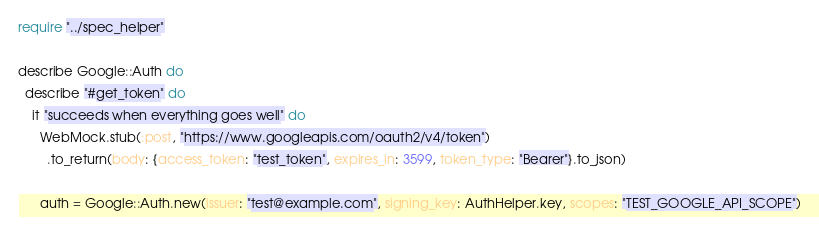<code> <loc_0><loc_0><loc_500><loc_500><_Crystal_>require "../spec_helper"

describe Google::Auth do
  describe "#get_token" do
    it "succeeds when everything goes well" do
      WebMock.stub(:post, "https://www.googleapis.com/oauth2/v4/token")
        .to_return(body: {access_token: "test_token", expires_in: 3599, token_type: "Bearer"}.to_json)

      auth = Google::Auth.new(issuer: "test@example.com", signing_key: AuthHelper.key, scopes: "TEST_GOOGLE_API_SCOPE")</code> 